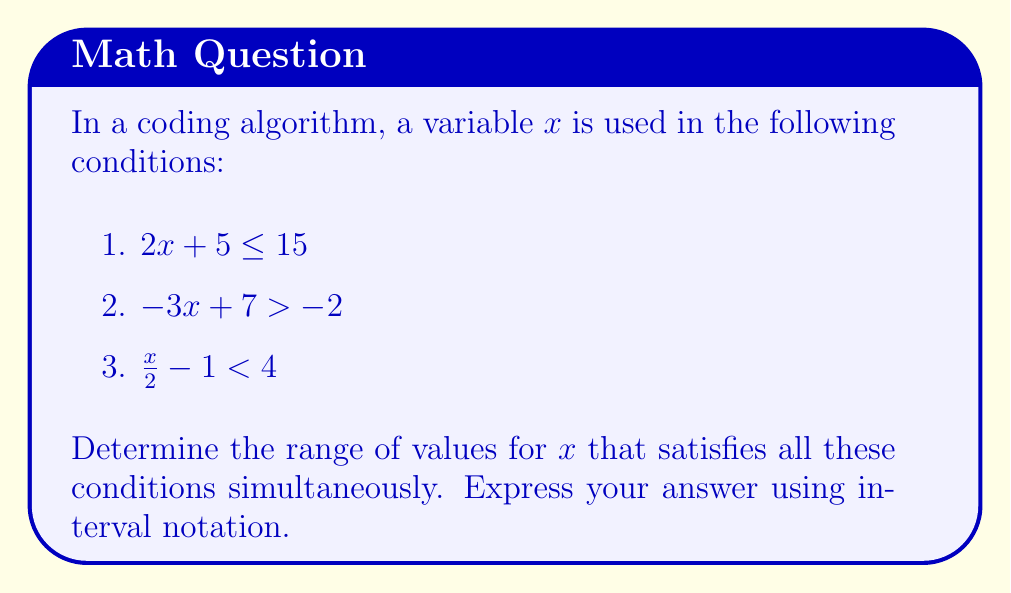Help me with this question. Let's solve this step-by-step:

1. From the first condition: $2x + 5 \leq 15$
   $$2x \leq 10$$
   $$x \leq 5$$

2. From the second condition: $-3x + 7 > -2$
   $$-3x > -9$$
   $$x < 3$$

3. From the third condition: $\frac{x}{2} - 1 < 4$
   $$\frac{x}{2} < 5$$
   $$x < 10$$

Now, we need to find the intersection of these three inequalities:

- $x \leq 5$ (from condition 1)
- $x < 3$ (from condition 2)
- $x < 10$ (from condition 3)

The most restrictive upper bound is 3, so $x < 3$.

For the lower bound, we need to consider the strict inequality from condition 2. Since $x$ is less than 3, the lower bound is the smallest possible value that satisfies all conditions. In this case, it's $-\infty$.

Therefore, the range of values for $x$ that satisfies all conditions is $(-\infty, 3)$.
Answer: $(-\infty, 3)$ 